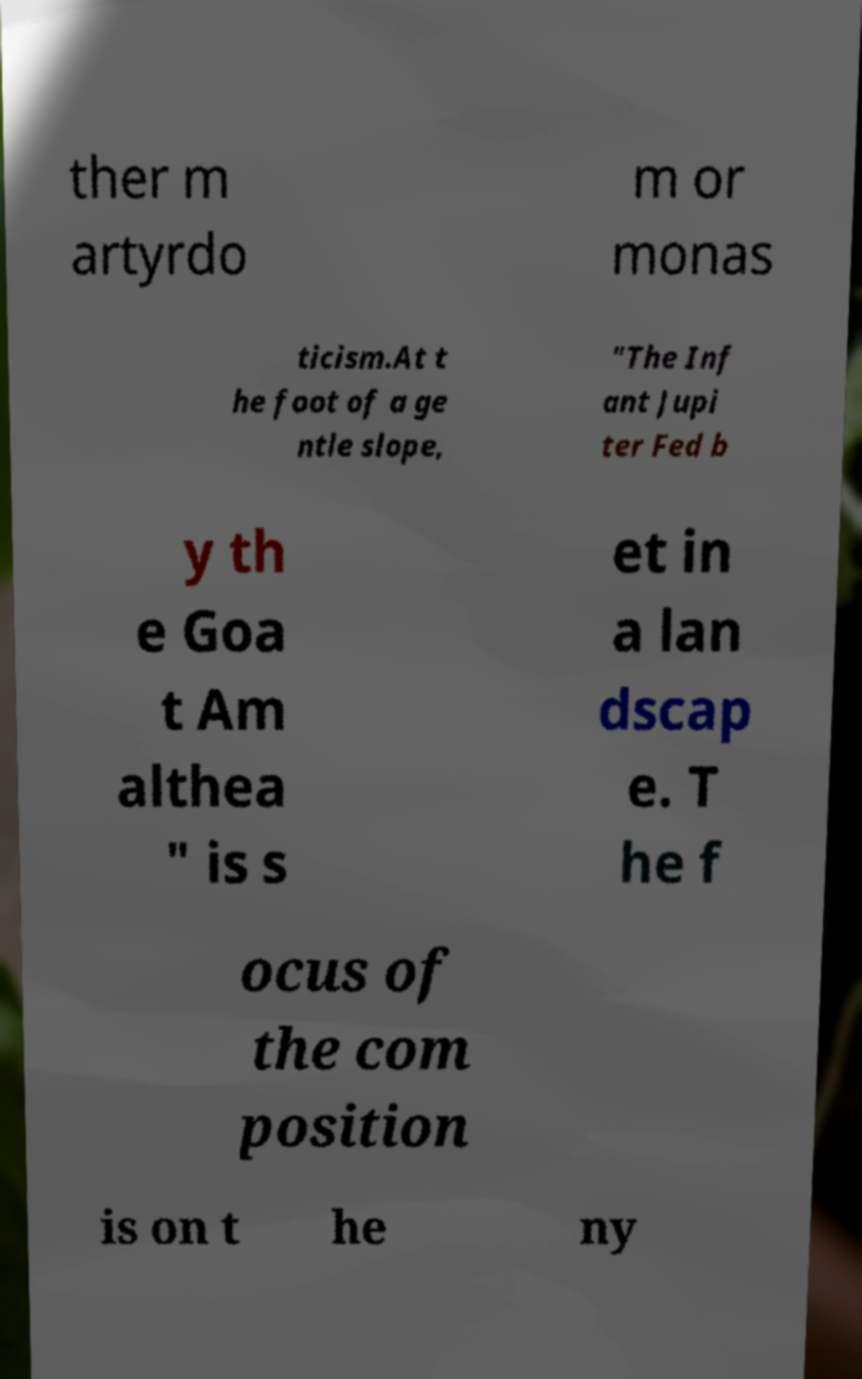For documentation purposes, I need the text within this image transcribed. Could you provide that? ther m artyrdo m or monas ticism.At t he foot of a ge ntle slope, "The Inf ant Jupi ter Fed b y th e Goa t Am althea " is s et in a lan dscap e. T he f ocus of the com position is on t he ny 